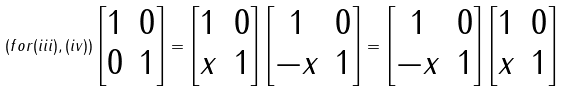Convert formula to latex. <formula><loc_0><loc_0><loc_500><loc_500>( f o r ( i i i ) , ( i v ) ) \begin{bmatrix} 1 & 0 \\ 0 & 1 \end{bmatrix} = \begin{bmatrix} 1 & 0 \\ x & 1 \end{bmatrix} \begin{bmatrix} 1 & 0 \\ - x & 1 \end{bmatrix} = \begin{bmatrix} 1 & 0 \\ - x & 1 \end{bmatrix} \begin{bmatrix} 1 & 0 \\ x & 1 \end{bmatrix}</formula> 